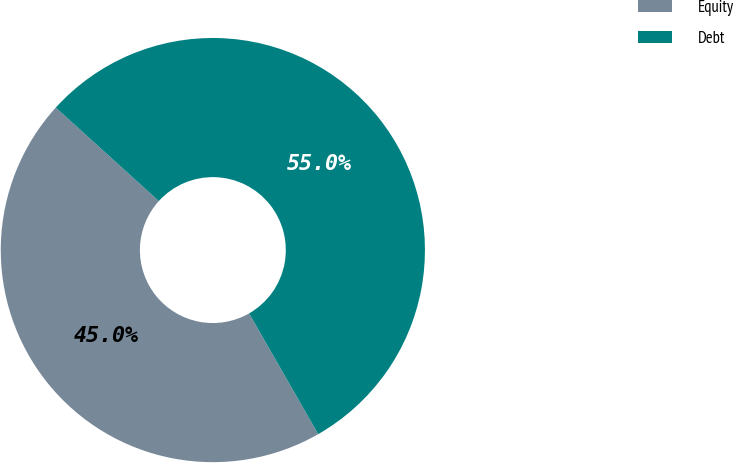Convert chart to OTSL. <chart><loc_0><loc_0><loc_500><loc_500><pie_chart><fcel>Equity<fcel>Debt<nl><fcel>45.0%<fcel>55.0%<nl></chart> 